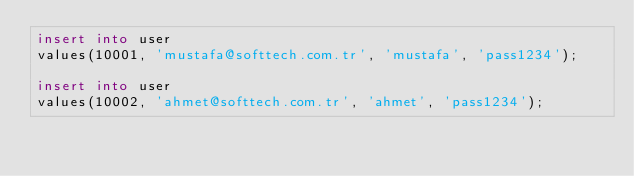Convert code to text. <code><loc_0><loc_0><loc_500><loc_500><_SQL_>insert into user
values(10001, 'mustafa@softtech.com.tr', 'mustafa', 'pass1234');

insert into user
values(10002, 'ahmet@softtech.com.tr', 'ahmet', 'pass1234');</code> 